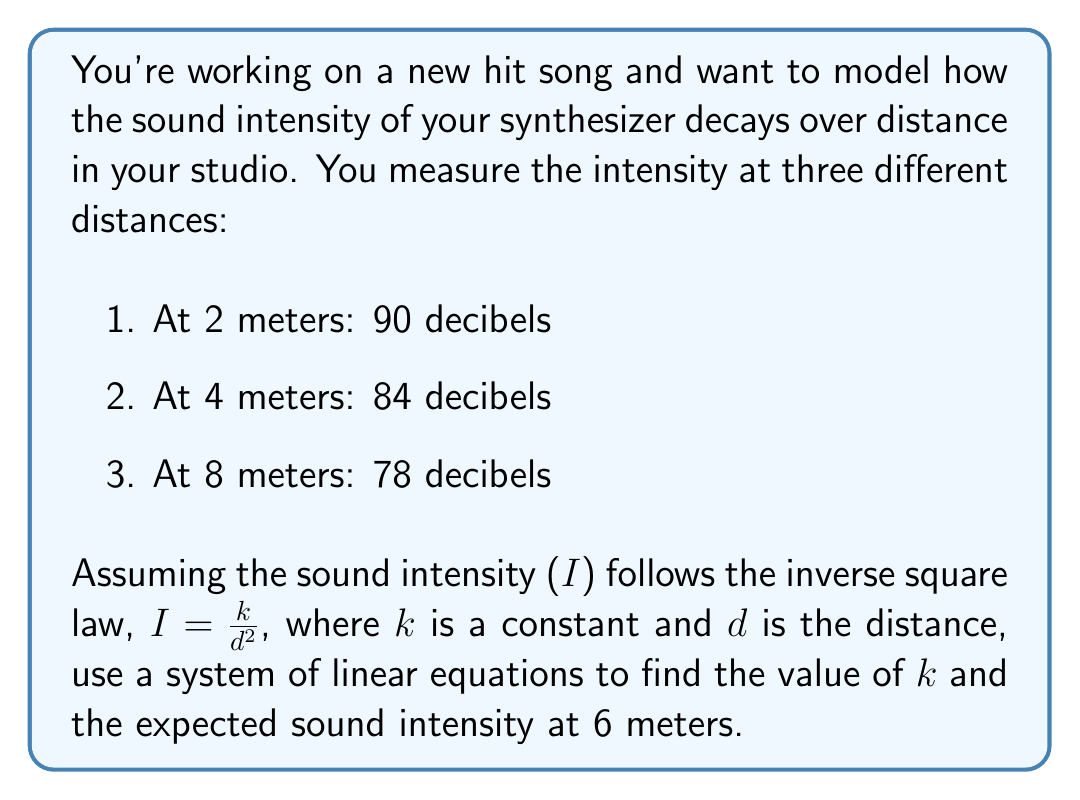Show me your answer to this math problem. Let's approach this step-by-step:

1) First, we need to convert the inverse square law into a linear equation. We can do this by taking the logarithm of both sides:

   $\log I = \log k - 2 \log d$

2) In acoustics, sound intensity level (SIL) in decibels is related to intensity by:

   $SIL = 10 \log_{10}(\frac{I}{I_0})$

   Where $I_0$ is a reference intensity. Let's call $\log k = a$ and $10 \log_{10} I_0 = b$. Then our equation becomes:

   $SIL = 10a - 20 \log d - b$

3) Now we can set up our system of linear equations using the given data:

   $90 = 10a - 20 \log 2 - b$
   $84 = 10a - 20 \log 4 - b$
   $78 = 10a - 20 \log 8 - b$

4) Subtracting the second equation from the first and the third from the second:

   $6 = 20 \log 4 - 20 \log 2 = 20 \log 2$
   $6 = 20 \log 8 - 20 \log 4 = 20 \log 2$

5) This confirms that our model fits the data. We can use any two equations to solve for $a$ and $b$. Let's use the first two:

   $90 = 10a - 20 \log 2 - b$
   $84 = 10a - 20 \log 4 - b$

6) Subtracting these equations:

   $6 = 20 \log 2$
   $a = \frac{6}{20} \log 2 = 0.3 \log 2 = 0.09$

7) Substituting this back into either equation:

   $90 = 10(0.09) - 20 \log 2 - b$
   $b = 90 - 0.9 - 20 \log 2 = 83.17$

8) Now we have our complete equation:

   $SIL = 0.9 - 20 \log d - 83.17$

9) To find the intensity at 6 meters, we simply substitute $d = 6$:

   $SIL = 0.9 - 20 \log 6 - 83.17 = 81.44$ decibels

10) To find $k$, we can use $k = 10^a = 10^{0.09} = 1.23$
Answer: $k = 1.23$, Sound intensity at 6 meters $= 81.44$ decibels 